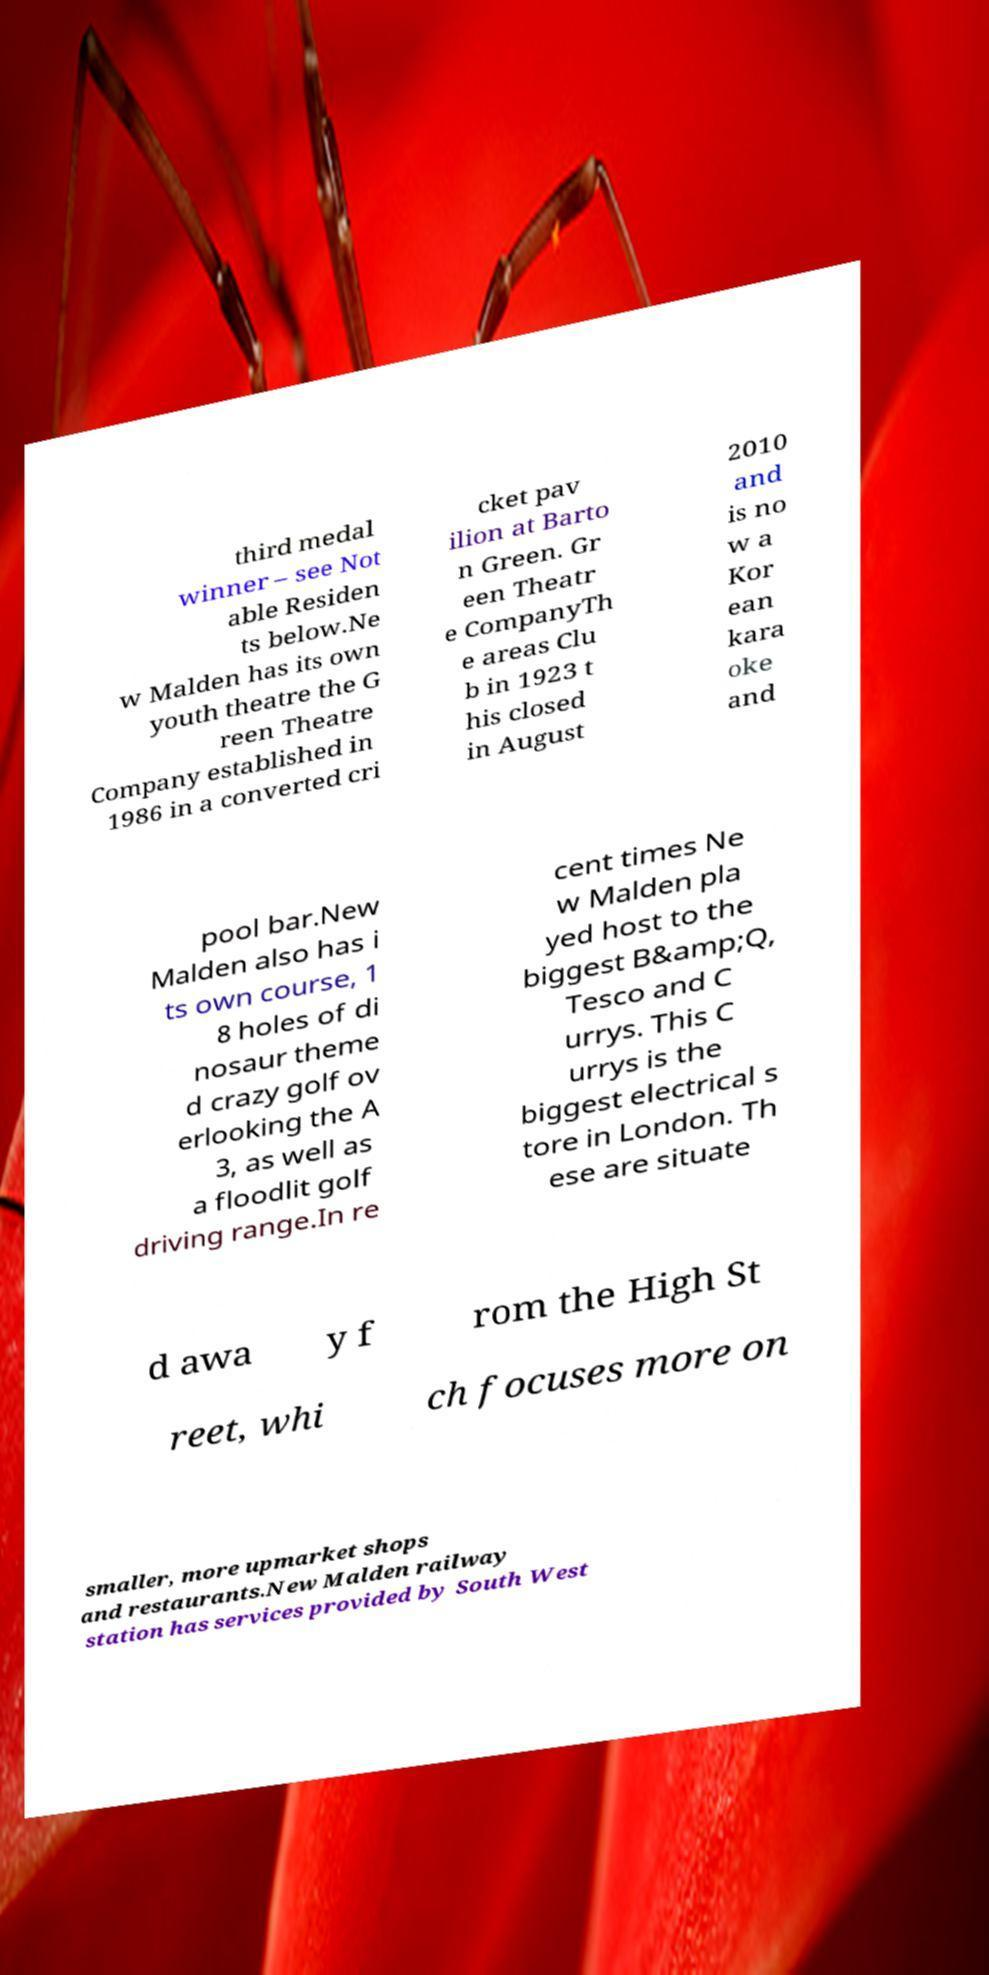Could you extract and type out the text from this image? third medal winner – see Not able Residen ts below.Ne w Malden has its own youth theatre the G reen Theatre Company established in 1986 in a converted cri cket pav ilion at Barto n Green. Gr een Theatr e CompanyTh e areas Clu b in 1923 t his closed in August 2010 and is no w a Kor ean kara oke and pool bar.New Malden also has i ts own course, 1 8 holes of di nosaur theme d crazy golf ov erlooking the A 3, as well as a floodlit golf driving range.In re cent times Ne w Malden pla yed host to the biggest B&amp;Q, Tesco and C urrys. This C urrys is the biggest electrical s tore in London. Th ese are situate d awa y f rom the High St reet, whi ch focuses more on smaller, more upmarket shops and restaurants.New Malden railway station has services provided by South West 